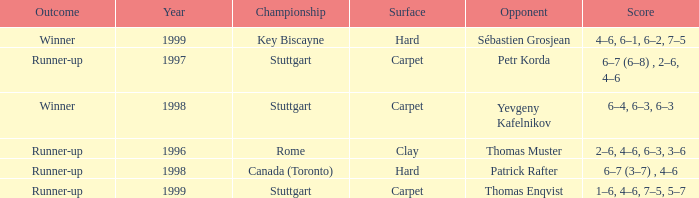How many years was the opponent petr korda? 1.0. 